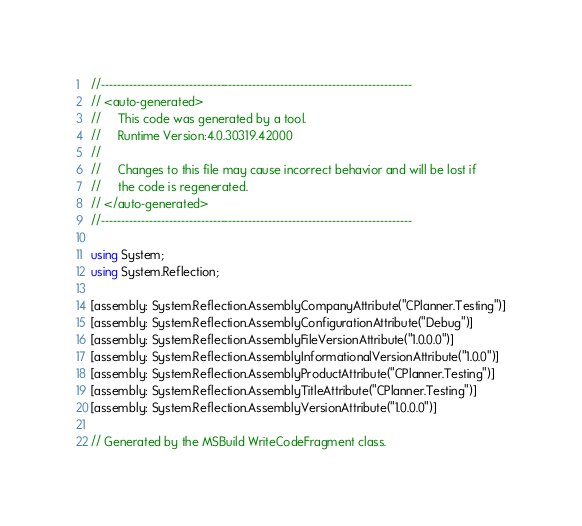<code> <loc_0><loc_0><loc_500><loc_500><_C#_>//------------------------------------------------------------------------------
// <auto-generated>
//     This code was generated by a tool.
//     Runtime Version:4.0.30319.42000
//
//     Changes to this file may cause incorrect behavior and will be lost if
//     the code is regenerated.
// </auto-generated>
//------------------------------------------------------------------------------

using System;
using System.Reflection;

[assembly: System.Reflection.AssemblyCompanyAttribute("CPlanner.Testing")]
[assembly: System.Reflection.AssemblyConfigurationAttribute("Debug")]
[assembly: System.Reflection.AssemblyFileVersionAttribute("1.0.0.0")]
[assembly: System.Reflection.AssemblyInformationalVersionAttribute("1.0.0")]
[assembly: System.Reflection.AssemblyProductAttribute("CPlanner.Testing")]
[assembly: System.Reflection.AssemblyTitleAttribute("CPlanner.Testing")]
[assembly: System.Reflection.AssemblyVersionAttribute("1.0.0.0")]

// Generated by the MSBuild WriteCodeFragment class.

</code> 